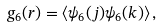Convert formula to latex. <formula><loc_0><loc_0><loc_500><loc_500>g _ { 6 } ( r ) = \left \langle \psi _ { 6 } ( j ) \psi _ { 6 } ( k ) \right \rangle ,</formula> 